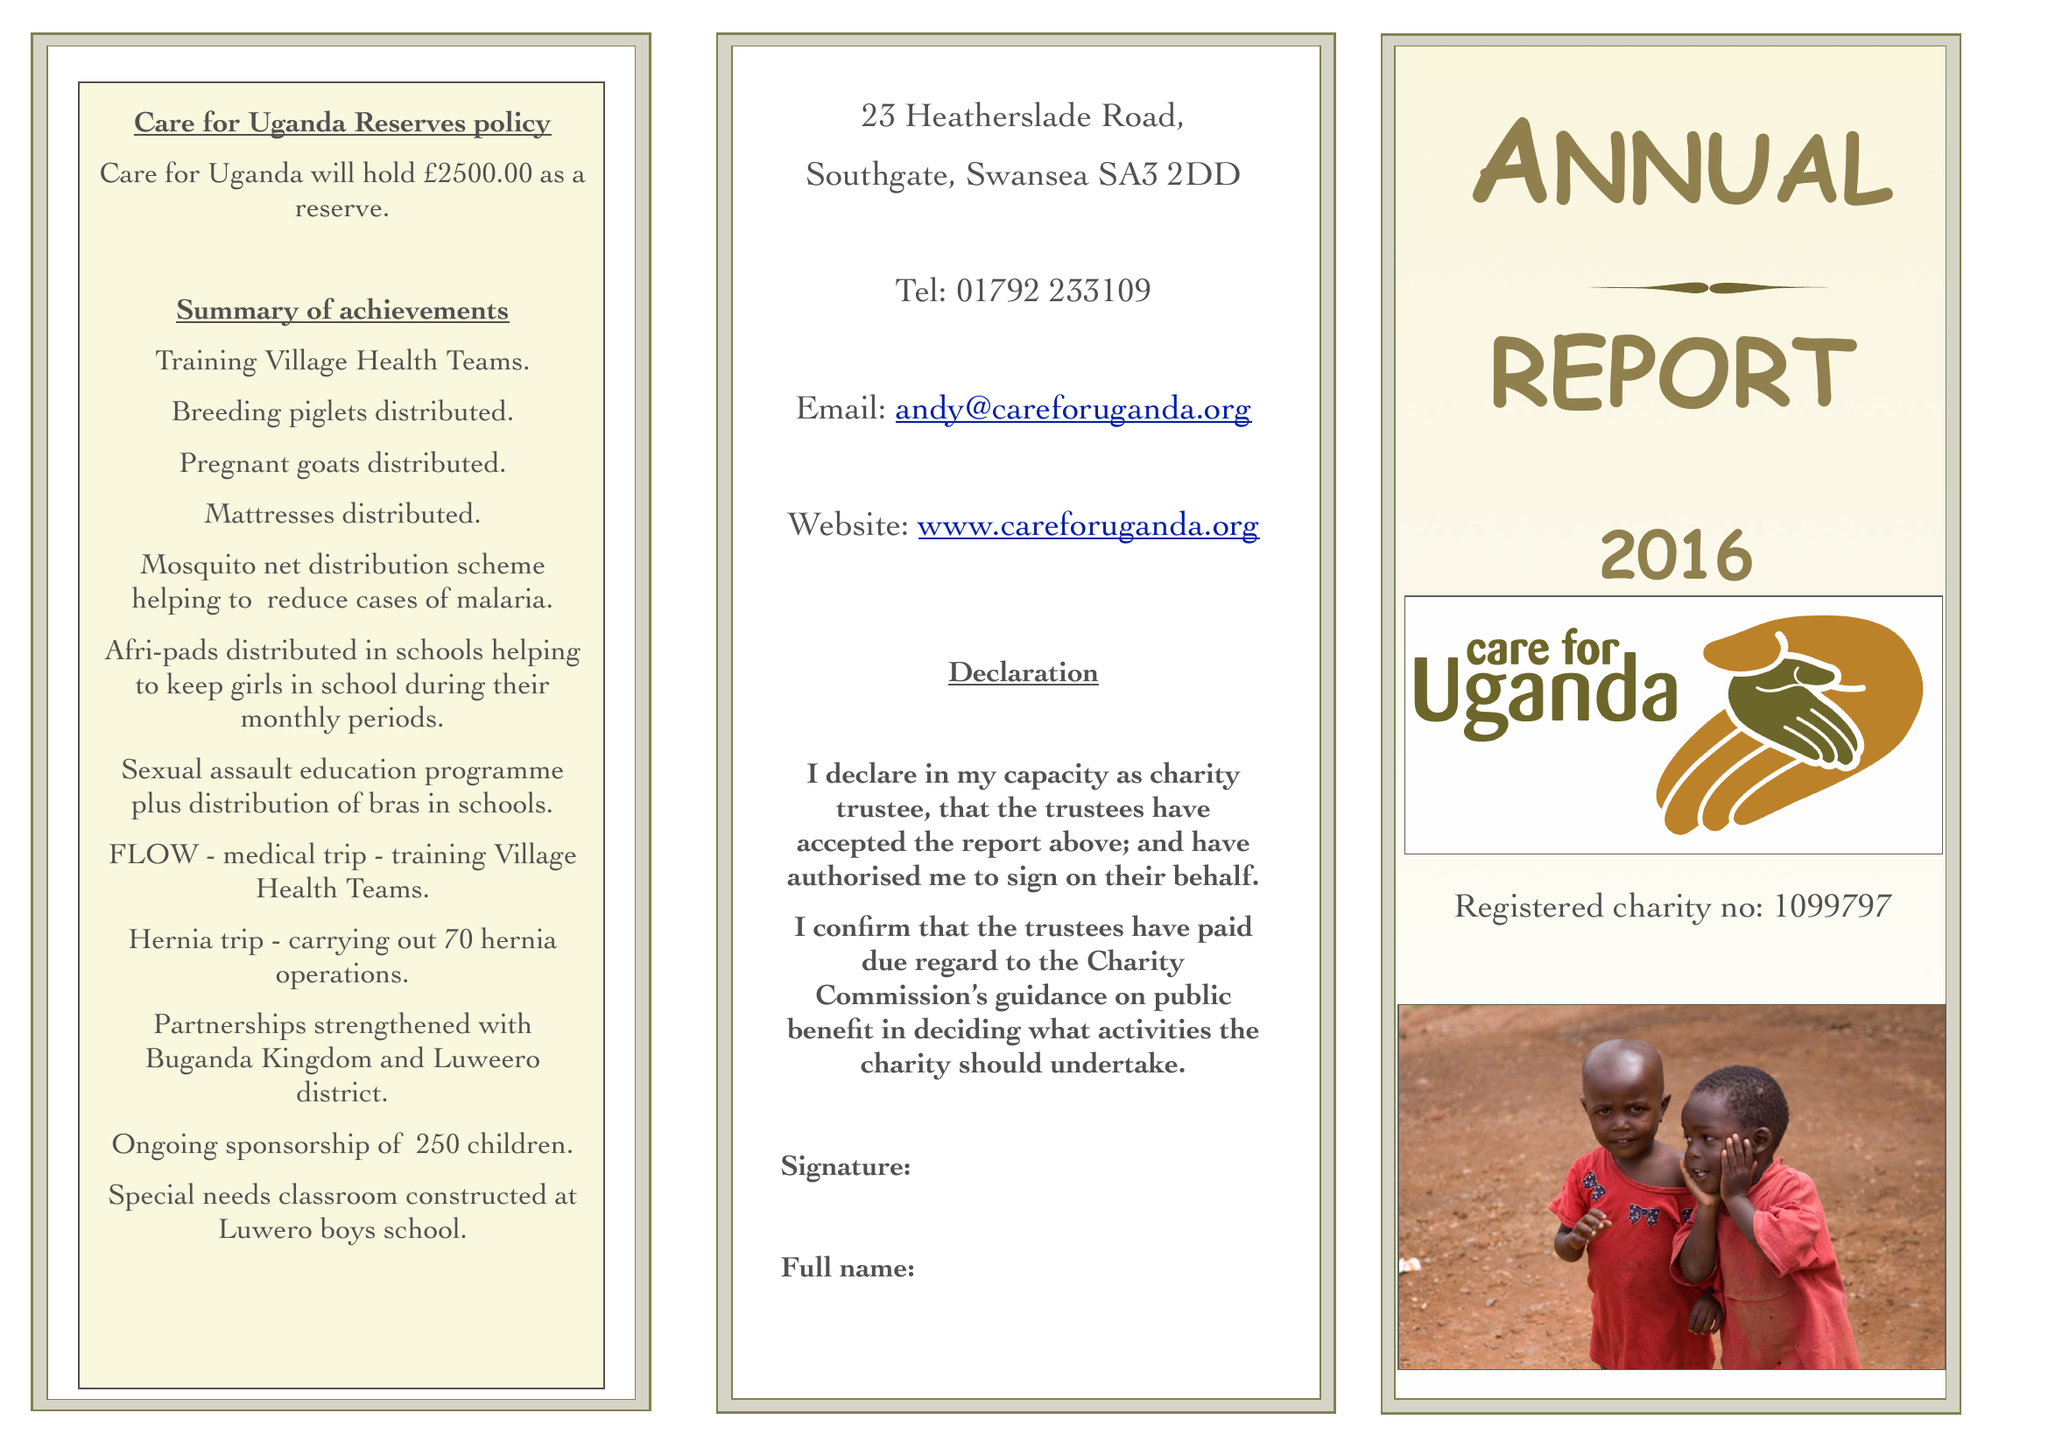What is the value for the address__street_line?
Answer the question using a single word or phrase. 23 HEATHERSLADE ROAD 